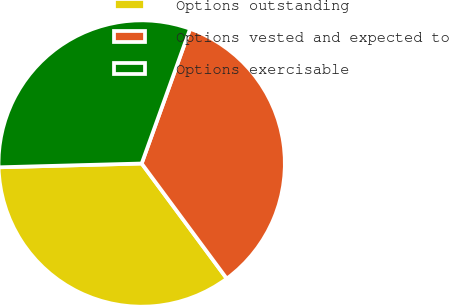<chart> <loc_0><loc_0><loc_500><loc_500><pie_chart><fcel>Options outstanding<fcel>Options vested and expected to<fcel>Options exercisable<nl><fcel>34.71%<fcel>34.38%<fcel>30.91%<nl></chart> 